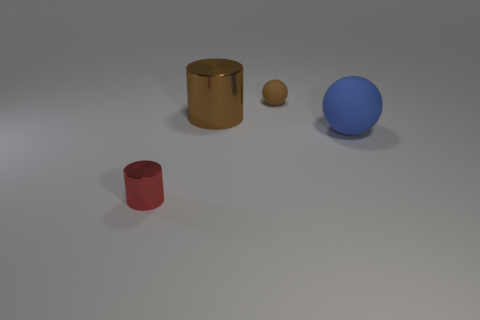Do the small metal thing and the metallic object that is behind the big rubber thing have the same shape?
Your response must be concise. Yes. Is the number of big blue matte things greater than the number of balls?
Keep it short and to the point. No. Does the shiny thing behind the red shiny object have the same shape as the small red shiny object?
Keep it short and to the point. Yes. Is the number of small things in front of the large metal cylinder greater than the number of big cyan rubber spheres?
Ensure brevity in your answer.  Yes. The metal thing that is right of the red thing to the left of the small rubber sphere is what color?
Your response must be concise. Brown. What number of tiny things are there?
Your response must be concise. 2. How many tiny things are both on the left side of the small brown rubber sphere and to the right of the small metal thing?
Ensure brevity in your answer.  0. There is a large metal object; does it have the same color as the small object that is behind the red shiny cylinder?
Ensure brevity in your answer.  Yes. What is the shape of the shiny object behind the red shiny thing?
Your answer should be compact. Cylinder. How many other objects are the same material as the big blue thing?
Your answer should be compact. 1. 